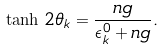Convert formula to latex. <formula><loc_0><loc_0><loc_500><loc_500>\tanh \, 2 \theta _ { k } = \frac { n g } { \epsilon _ { k } ^ { 0 } + n g } .</formula> 